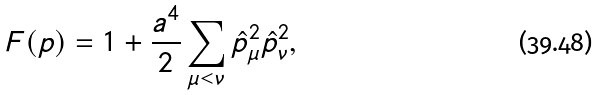Convert formula to latex. <formula><loc_0><loc_0><loc_500><loc_500>F ( p ) = 1 + \frac { a ^ { 4 } } { 2 } \sum _ { \mu < \nu } \hat { p } _ { \mu } ^ { 2 } \hat { p } _ { \nu } ^ { 2 } ,</formula> 